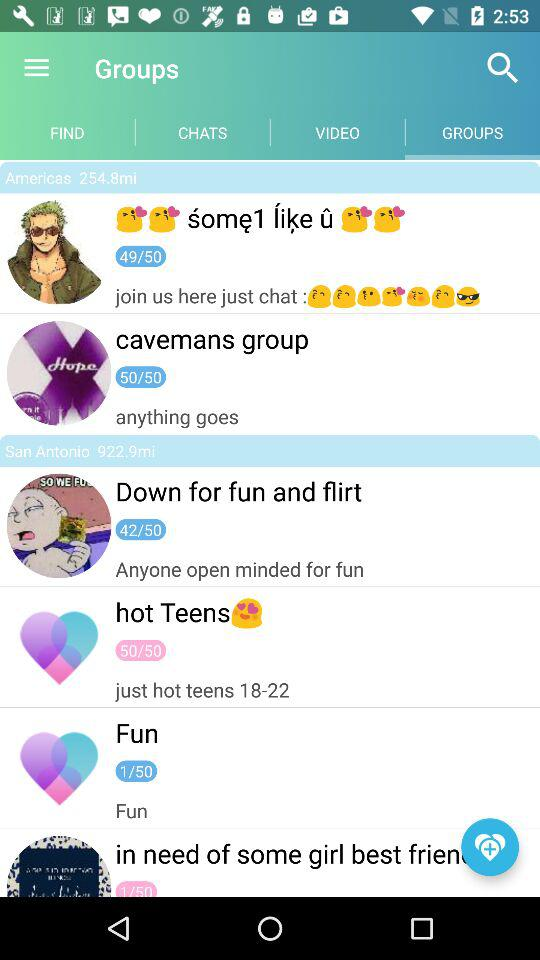Which chat was sent at 12:23?
When the provided information is insufficient, respond with <no answer>. <no answer> 